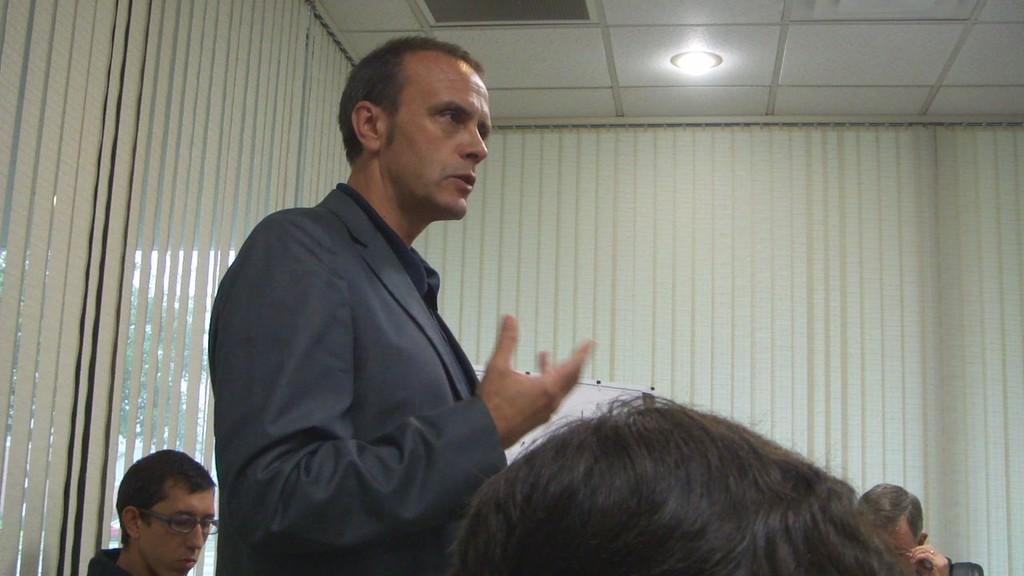Describe this image in one or two sentences. At the top we can see the ceiling and light. In the background we can see a window blind and a whiteboard. In this picture we can see a man is standing. We can see the faces of the people and they wore spectacles. At the bottom portion of the picture we can see a person's head. 